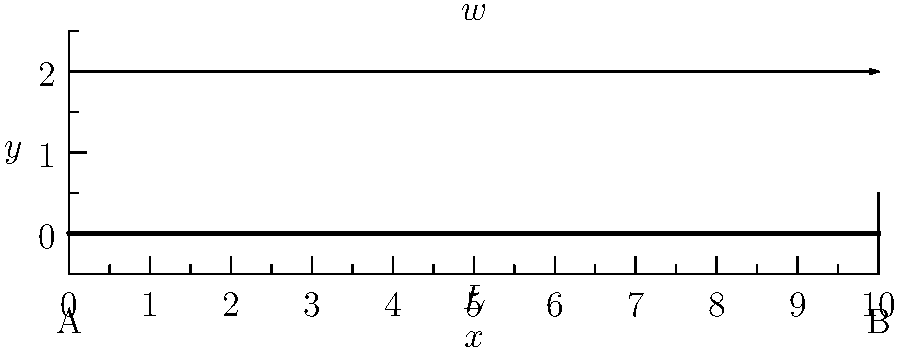Consider a simply supported beam of length $L$ subjected to a uniformly distributed load $w$ per unit length, as shown in the figure. Derive expressions for the shear force $V(x)$ and bending moment $M(x)$ at any point $x$ along the beam. Then, sketch the shear force and bending moment diagrams, identifying the maximum values and their locations. 1. Reaction forces:
   Due to symmetry, $R_A = R_B = \frac{wL}{2}$

2. Shear force equation:
   $$V(x) = R_A - wx = \frac{wL}{2} - wx$$

3. Bending moment equation:
   $$M(x) = R_A x - \frac{wx^2}{2} = \frac{wLx}{2} - \frac{wx^2}{2}$$

4. Shear force diagram:
   - At $x = 0$: $V(0) = \frac{wL}{2}$
   - At $x = L$: $V(L) = -\frac{wL}{2}$
   - $V(x) = 0$ when $x = \frac{L}{2}$

5. Bending moment diagram:
   - At $x = 0$ and $x = L$: $M(0) = M(L) = 0$
   - Maximum bending moment occurs at $x = \frac{L}{2}$:
     $$M_{max} = M(\frac{L}{2}) = \frac{wL^2}{8}$$

6. Sketches:
   - Shear force diagram: Linear, from $\frac{wL}{2}$ at $x = 0$ to $-\frac{wL}{2}$ at $x = L$
   - Bending moment diagram: Parabolic, with maximum $\frac{wL^2}{8}$ at $x = \frac{L}{2}$
Answer: $V(x) = \frac{wL}{2} - wx$, $M(x) = \frac{wLx}{2} - \frac{wx^2}{2}$; $V_{max} = \frac{wL}{2}$ at $x = 0$ and $x = L$, $M_{max} = \frac{wL^2}{8}$ at $x = \frac{L}{2}$ 